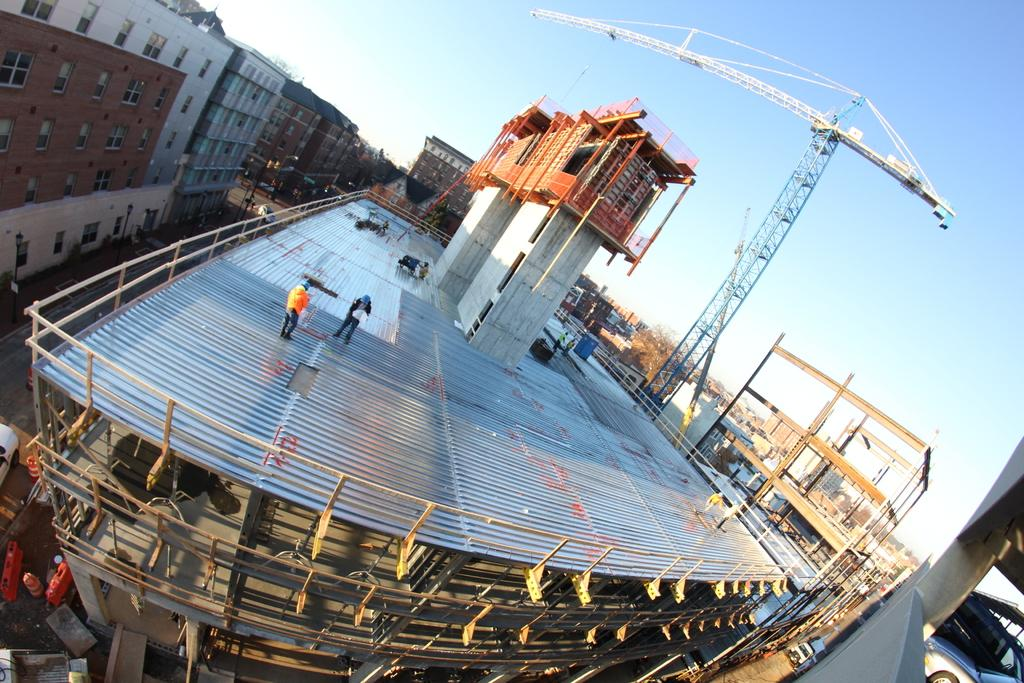What is happening in the image? Construction work is taking place in the image. What can be seen behind the building where the construction is happening? There is a huge crane behind the building. What is the surrounding area like in the image? There are many houses and other buildings around the construction site. Where is the playground located in the image? There is no playground present in the image; it focuses on construction work and the surrounding buildings. What type of badge is being worn by the construction workers in the image? There is no information about badges or any specific workers in the image, as it only shows the construction site and the crane. 